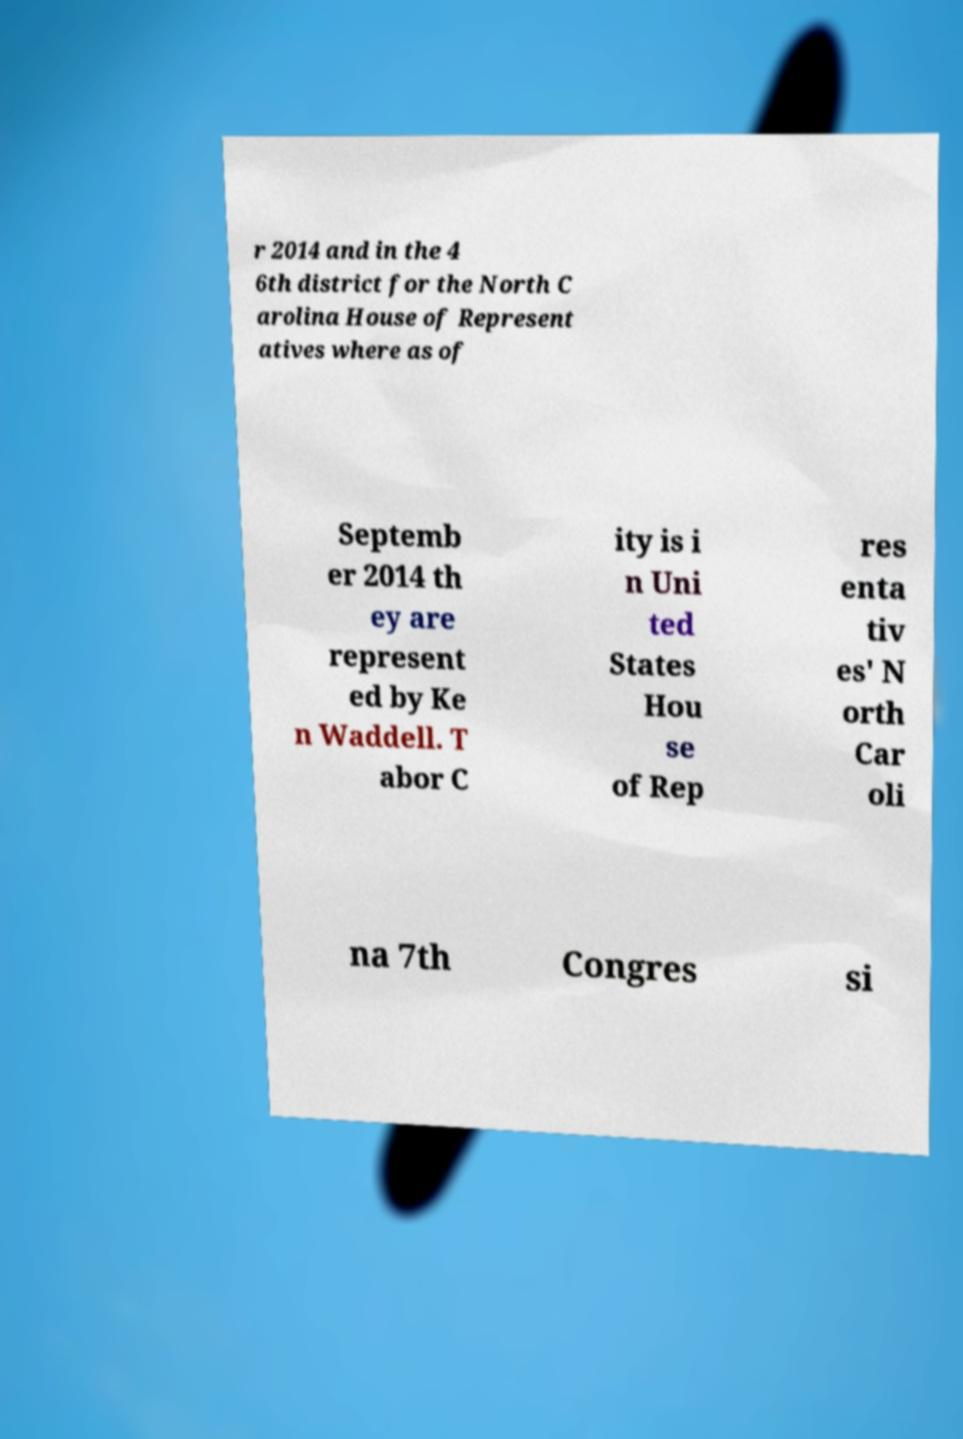There's text embedded in this image that I need extracted. Can you transcribe it verbatim? r 2014 and in the 4 6th district for the North C arolina House of Represent atives where as of Septemb er 2014 th ey are represent ed by Ke n Waddell. T abor C ity is i n Uni ted States Hou se of Rep res enta tiv es' N orth Car oli na 7th Congres si 